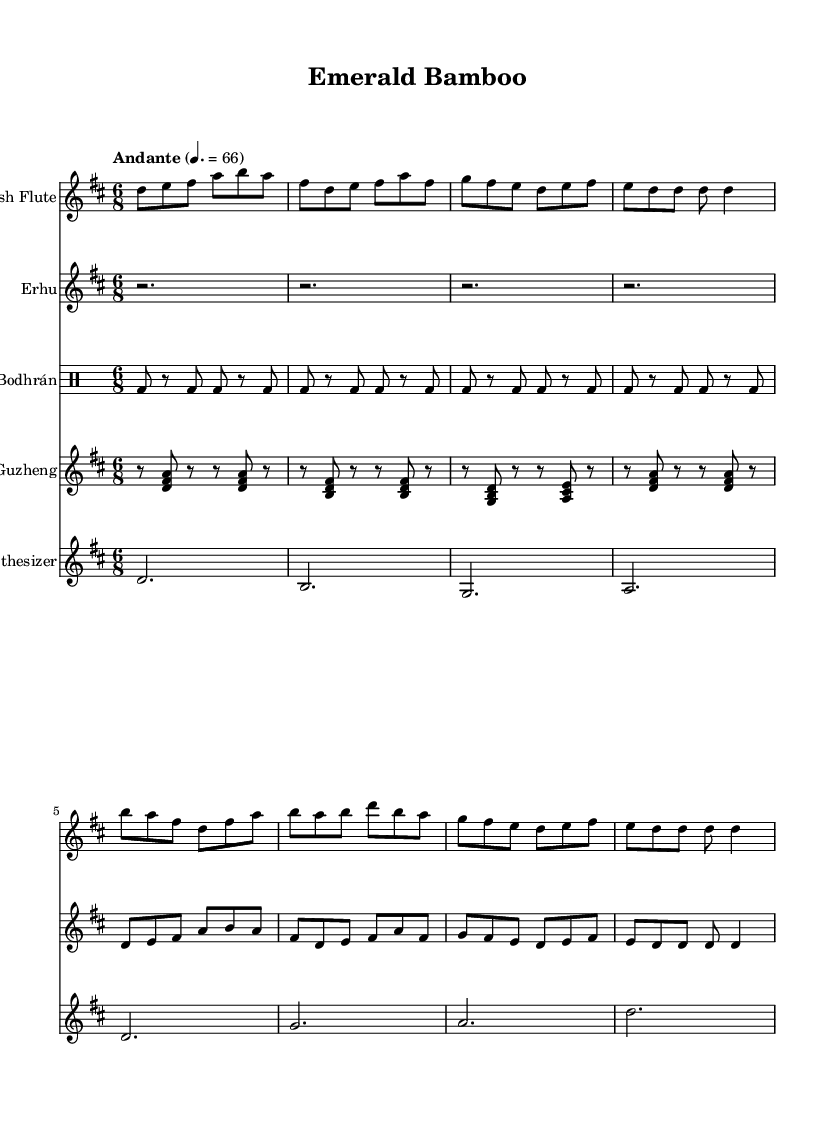What is the key signature of this music? The key signature indicates the music is in D major, which has two sharps: F sharp and C sharp. This can be deduced from the global section where the key is set.
Answer: D major What is the time signature of this piece? The time signature is found in the global section specifying the rhythm structure of the music. In this case, it's 6/8, meaning there are six eighth notes per measure.
Answer: 6/8 What is the tempo marking of the piece? Tempo markings can be found in the global section as well. Here, it shows "Andante" with a metronome marking of 66, which indicates a moderately slow tempo.
Answer: Andante 4. = 66 Which instrument has the highest pitch in the score? By analyzing the pitch ranges of the instruments, the Irish flute typically plays higher than the other instruments presented. When comparing the note values played, the flute consistently has the highest pitches.
Answer: Irish Flute How many measures does the flute part have? Counting the measures in the flute part from the provided notes, there are a total of 8 measures present, each separated by a bar line.
Answer: 8 measures Which two instruments are playing simultaneously in the first section of the score? Examining the score, the Irish flute and erhu are the two instruments that play notes at the same time in the initial sections. This can be seen as their notes align vertically.
Answer: Flute and Erhu What role does the synthesizer play in this composition? The synthesizer appears to provide harmonic support and sustains a drone, simplifying the rhythmic texture while accompanying the melodic instruments. This support is indicated by long, sustained notes.
Answer: Harmonic support 